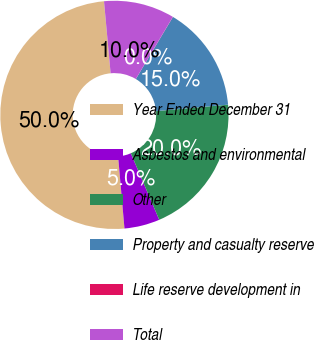<chart> <loc_0><loc_0><loc_500><loc_500><pie_chart><fcel>Year Ended December 31<fcel>Asbestos and environmental<fcel>Other<fcel>Property and casualty reserve<fcel>Life reserve development in<fcel>Total<nl><fcel>49.95%<fcel>5.02%<fcel>20.0%<fcel>15.0%<fcel>0.02%<fcel>10.01%<nl></chart> 